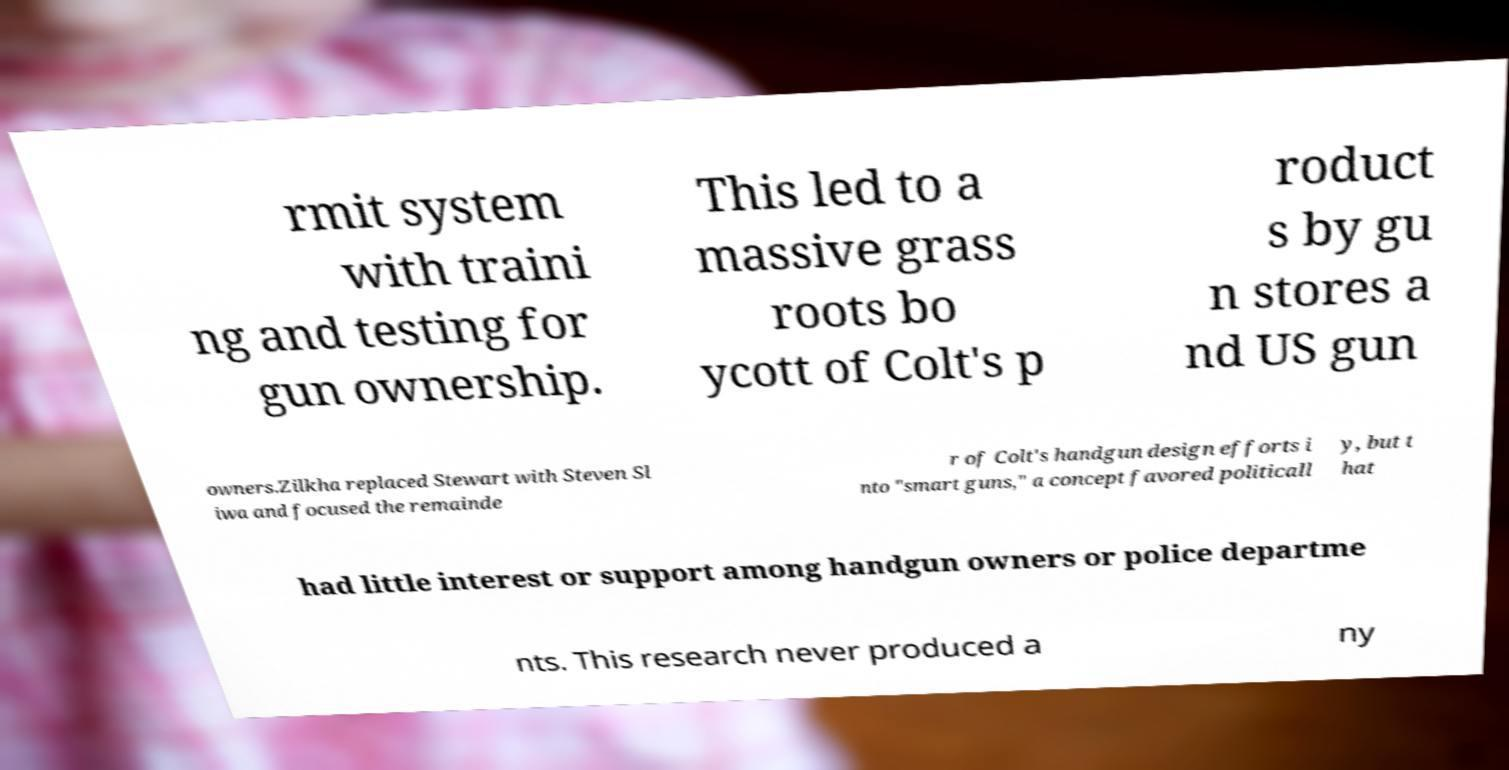Can you accurately transcribe the text from the provided image for me? rmit system with traini ng and testing for gun ownership. This led to a massive grass roots bo ycott of Colt's p roduct s by gu n stores a nd US gun owners.Zilkha replaced Stewart with Steven Sl iwa and focused the remainde r of Colt's handgun design efforts i nto "smart guns," a concept favored politicall y, but t hat had little interest or support among handgun owners or police departme nts. This research never produced a ny 